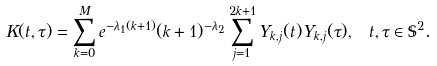<formula> <loc_0><loc_0><loc_500><loc_500>K ( t , \tau ) = \sum _ { k = 0 } ^ { M } e ^ { - \lambda _ { 1 } ( k + 1 ) } ( k + 1 ) ^ { - \lambda _ { 2 } } \sum _ { j = 1 } ^ { 2 k + 1 } Y _ { k , j } ( t ) Y _ { k , j } ( \tau ) , \ t , \tau \in \mathbb { S } ^ { 2 } .</formula> 